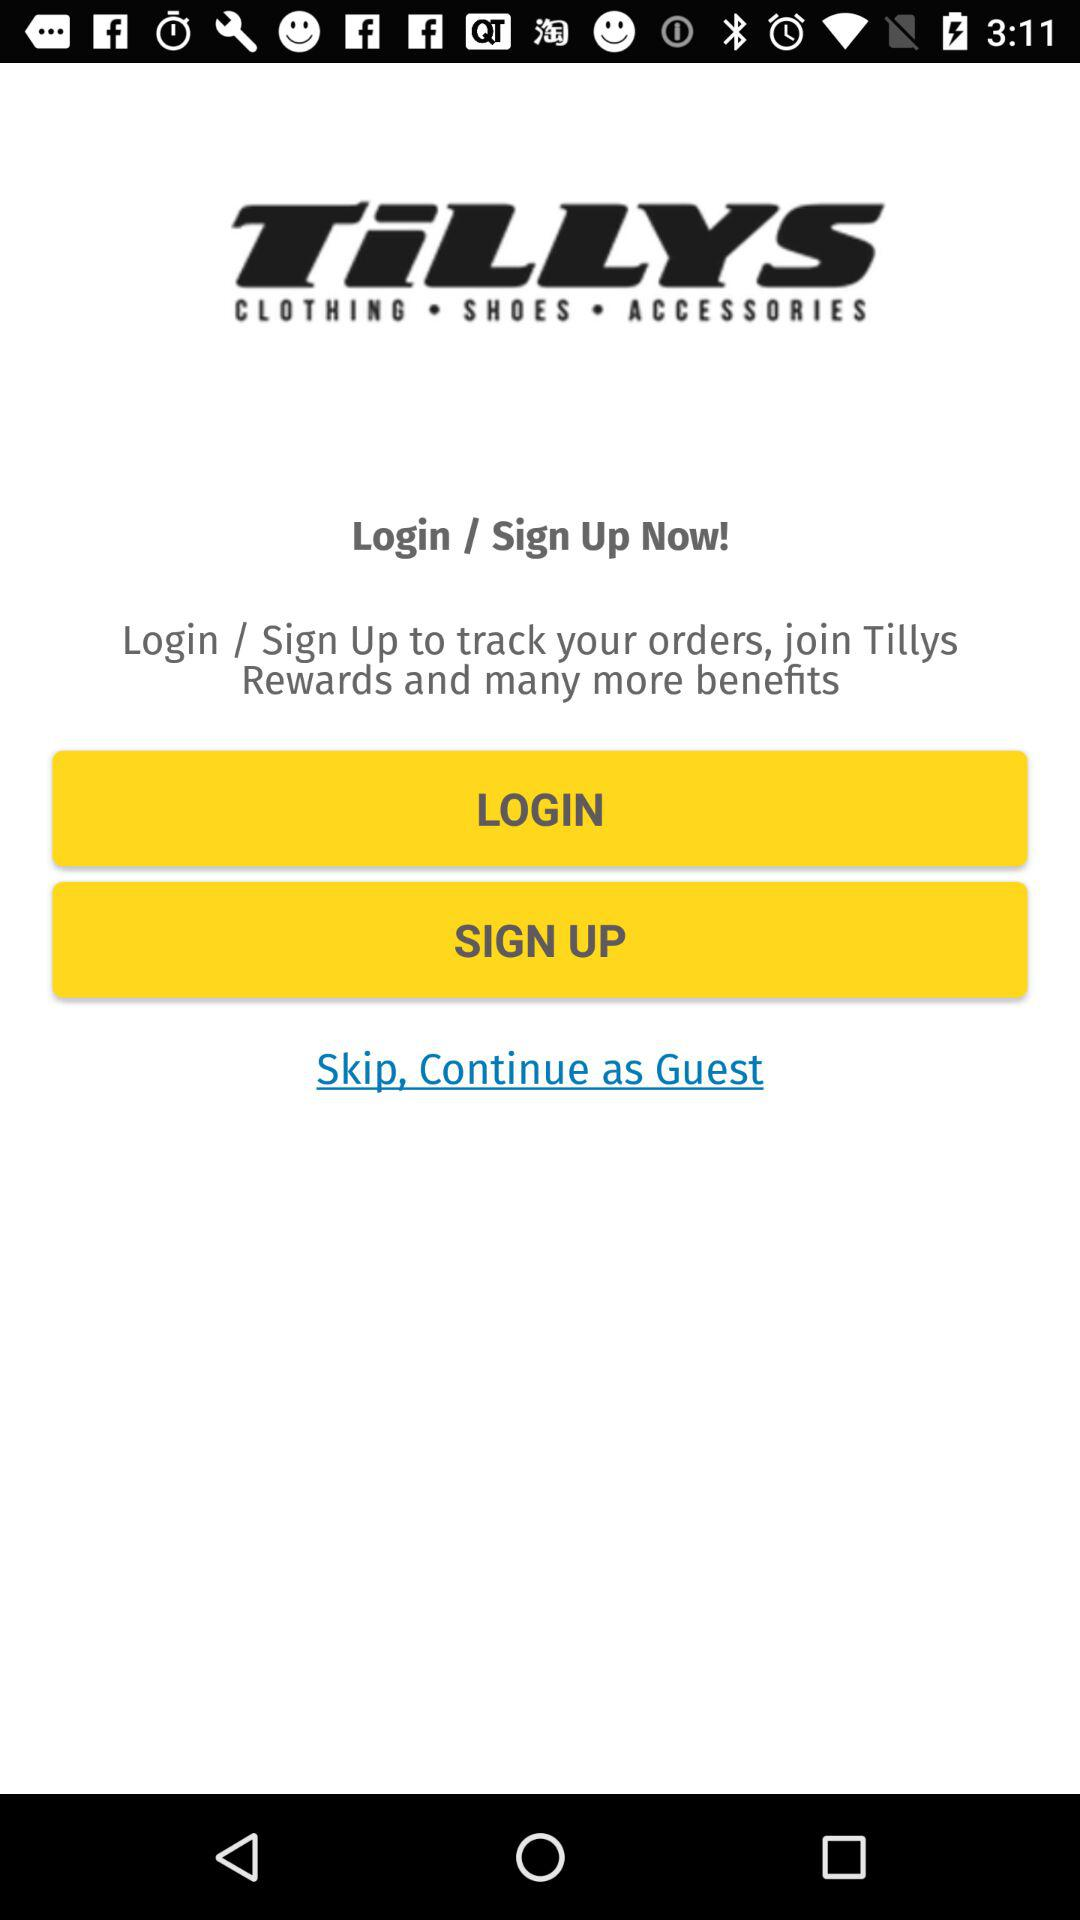What is the name of the application? The application's name is "Tillys", which is a retail clothing company. Through their app, users can log in or sign up to track their orders, join the Tillys Rewards program, and enjoy other membership benefits. 